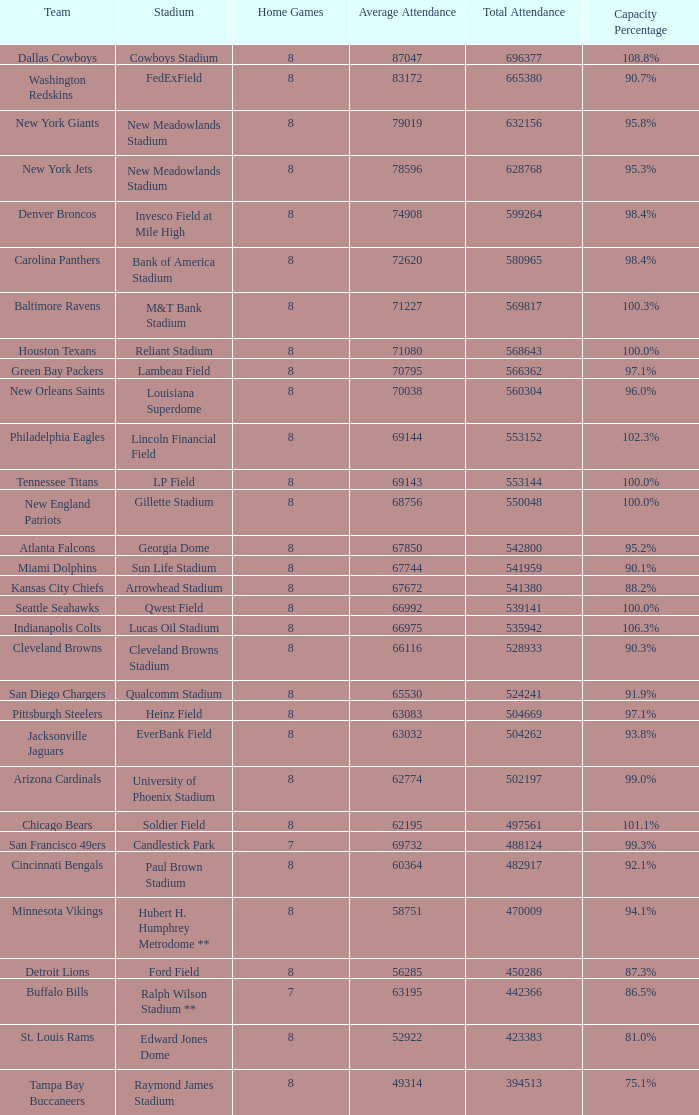What was the cumulative attendance figure for the new york giants? 632156.0. 